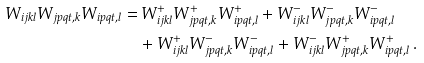<formula> <loc_0><loc_0><loc_500><loc_500>W _ { i j k l } W _ { j p q t , k } W _ { i p q t , l } = & \, W ^ { + } _ { i j k l } W ^ { + } _ { j p q t , k } W ^ { + } _ { i p q t , l } + W ^ { - } _ { i j k l } W ^ { - } _ { j p q t , k } W ^ { - } _ { i p q t , l } \\ & + W _ { i j k l } ^ { + } W ^ { - } _ { j p q t , k } W ^ { - } _ { i p q t , l } + W _ { i j k l } ^ { - } W ^ { + } _ { j p q t , k } W ^ { + } _ { i p q t , l } \, .</formula> 